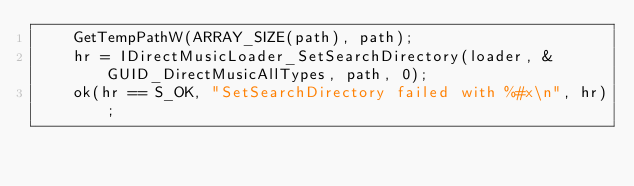Convert code to text. <code><loc_0><loc_0><loc_500><loc_500><_C_>    GetTempPathW(ARRAY_SIZE(path), path);
    hr = IDirectMusicLoader_SetSearchDirectory(loader, &GUID_DirectMusicAllTypes, path, 0);
    ok(hr == S_OK, "SetSearchDirectory failed with %#x\n", hr);</code> 